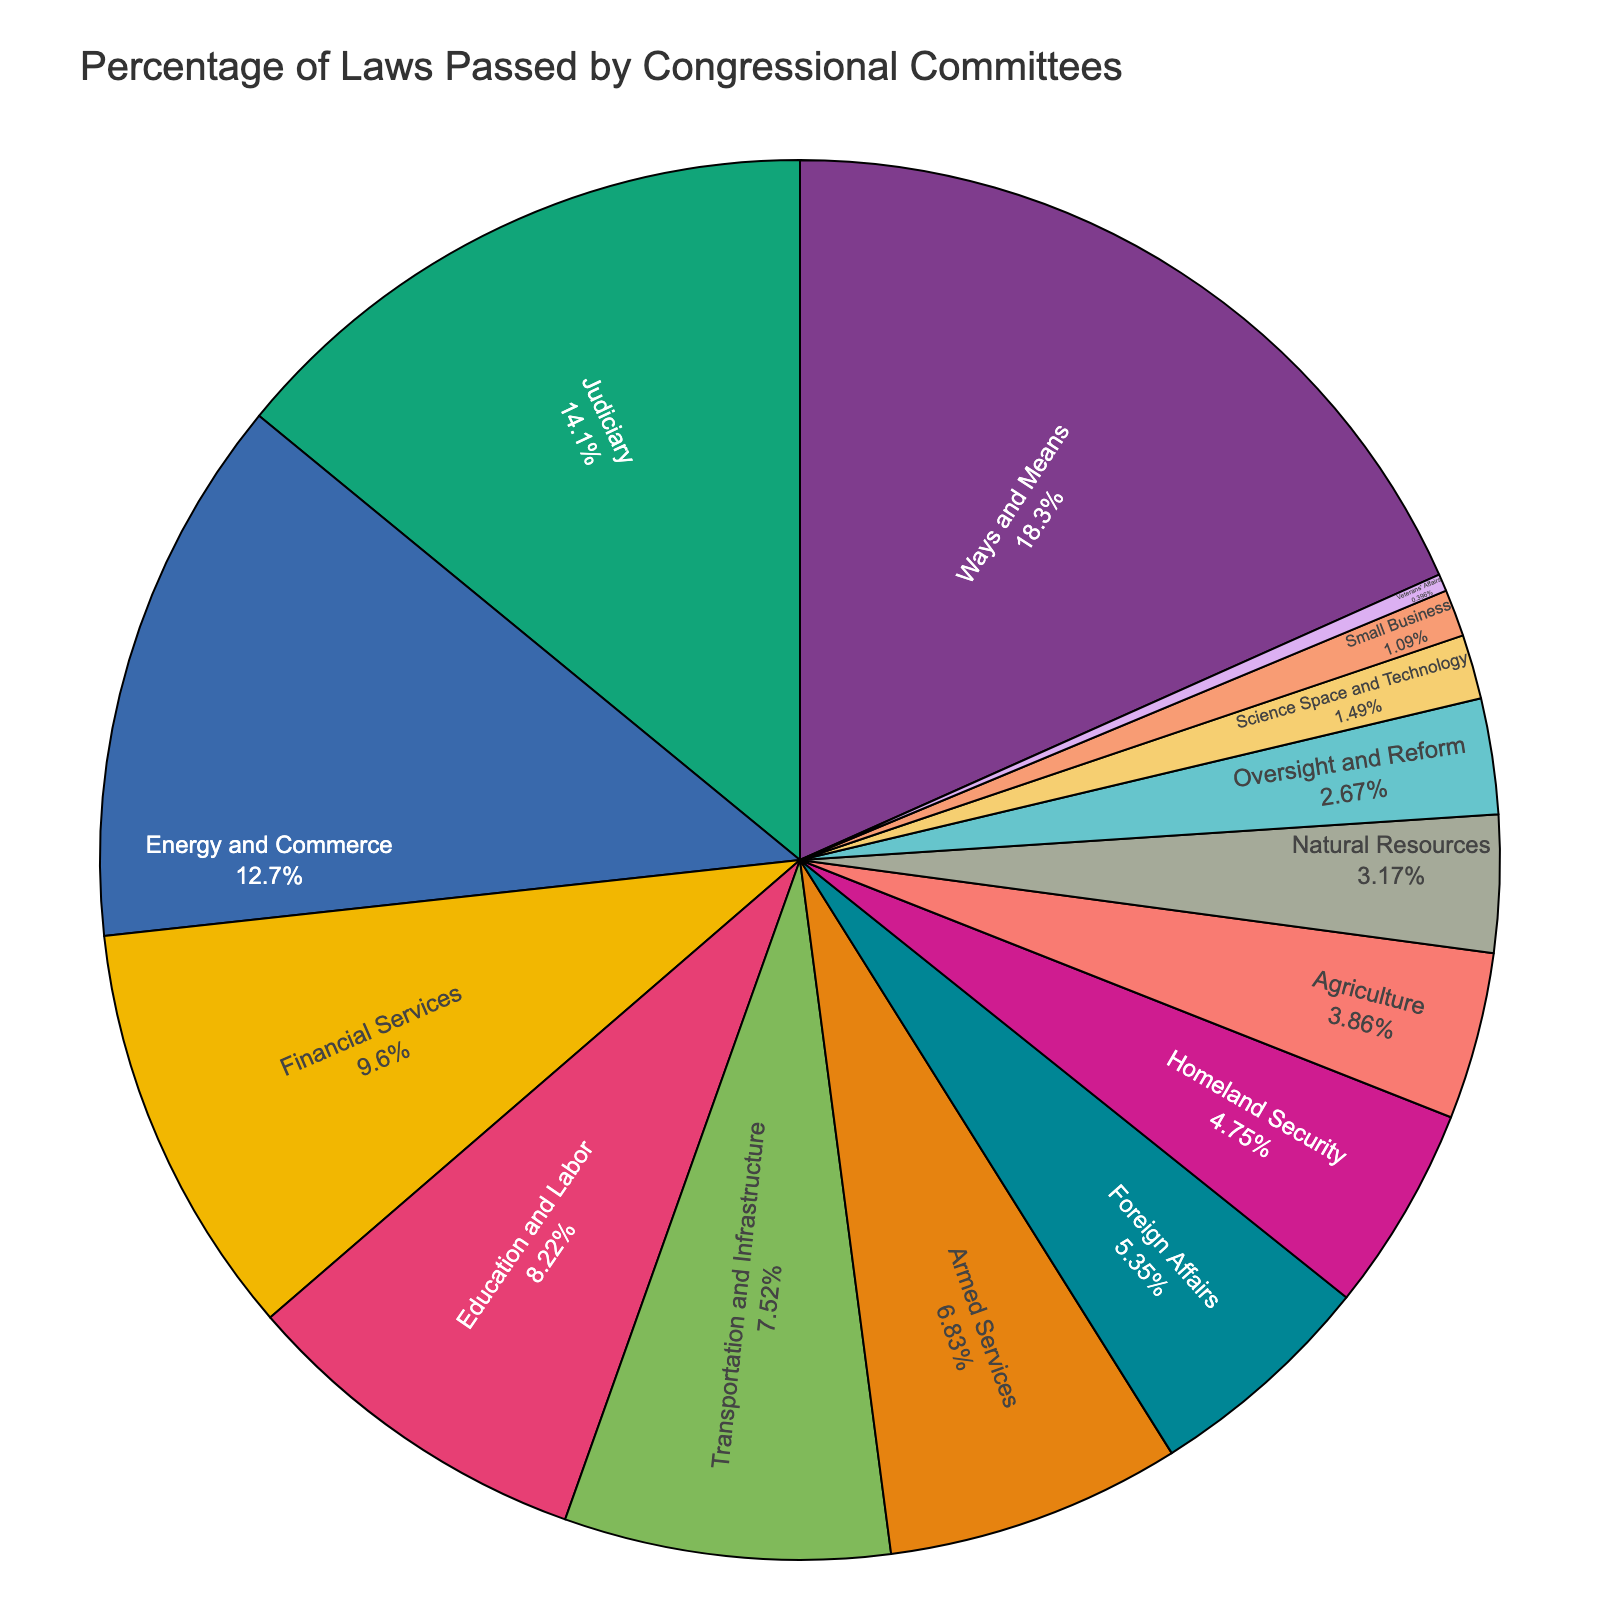What is the percentage of laws passed by the Ways and Means committee? The figure shows the percentage of laws passed by each committee, and we need to find the section labeled "Ways and Means" and note its percentage.
Answer: 18.5% Which committee passed the least percentage of laws? The segment labeled "Veterans' Affairs" has the smallest percentage.
Answer: Veterans' Affairs Which committee is responsible for passing just over 7% of laws and what is the exact percentage? The segment just over 7% is labeled "Transportation and Infrastructure" at 7.6%.
Answer: Transportation and Infrastructure, 7.6% Of the committees shown, which five committees passed the highest percentage of laws? Identify the top five segments by size: Ways and Means, Judiciary, Energy and Commerce, Financial Services, and Education and Labor.
Answer: Ways and Means, Judiciary, Energy and Commerce, Financial Services, Education and Labor Estimate the visual difference in size between the segments for the Financial Services committee and the Armed Services committee. The Financial Services segment (9.7%) is slightly larger than the Armed Services segment (6.9%). This visual difference is about 2.8%.
Answer: Financial Services is visually about 2.8% larger than Armed Services 